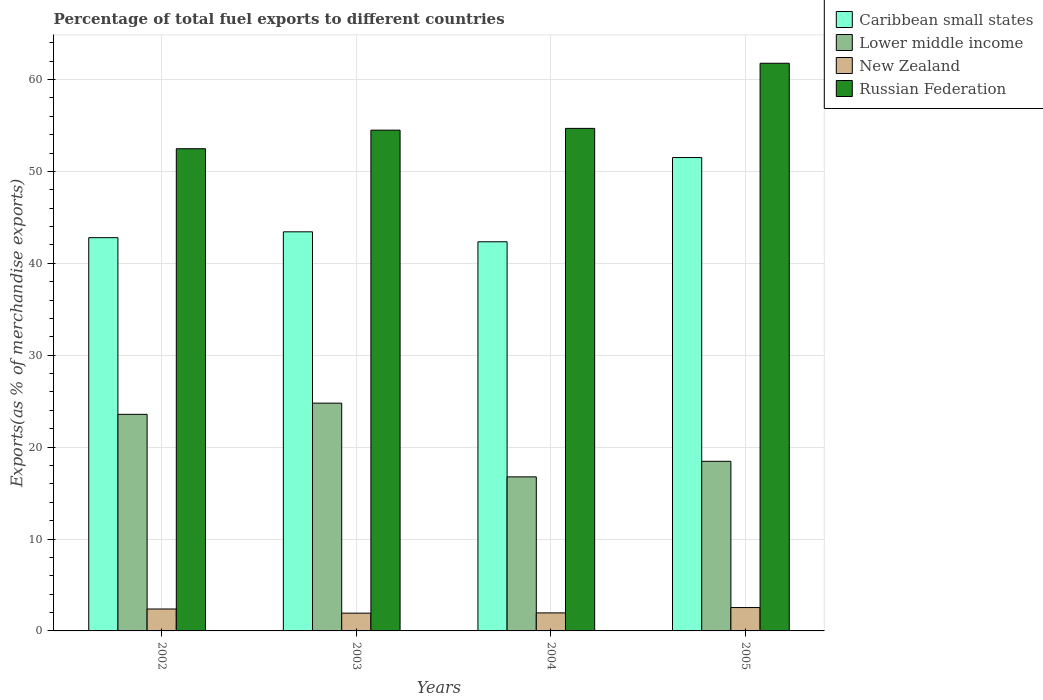Are the number of bars on each tick of the X-axis equal?
Make the answer very short. Yes. What is the percentage of exports to different countries in Russian Federation in 2003?
Provide a short and direct response. 54.49. Across all years, what is the maximum percentage of exports to different countries in New Zealand?
Provide a short and direct response. 2.54. Across all years, what is the minimum percentage of exports to different countries in Lower middle income?
Offer a terse response. 16.76. What is the total percentage of exports to different countries in Russian Federation in the graph?
Offer a terse response. 223.43. What is the difference between the percentage of exports to different countries in Lower middle income in 2004 and that in 2005?
Your response must be concise. -1.69. What is the difference between the percentage of exports to different countries in New Zealand in 2003 and the percentage of exports to different countries in Caribbean small states in 2004?
Give a very brief answer. -40.41. What is the average percentage of exports to different countries in Russian Federation per year?
Provide a succinct answer. 55.86. In the year 2005, what is the difference between the percentage of exports to different countries in Caribbean small states and percentage of exports to different countries in Lower middle income?
Keep it short and to the point. 33.05. What is the ratio of the percentage of exports to different countries in Lower middle income in 2003 to that in 2004?
Ensure brevity in your answer.  1.48. Is the percentage of exports to different countries in Russian Federation in 2002 less than that in 2004?
Offer a terse response. Yes. Is the difference between the percentage of exports to different countries in Caribbean small states in 2002 and 2005 greater than the difference between the percentage of exports to different countries in Lower middle income in 2002 and 2005?
Give a very brief answer. No. What is the difference between the highest and the second highest percentage of exports to different countries in Caribbean small states?
Give a very brief answer. 8.08. What is the difference between the highest and the lowest percentage of exports to different countries in Russian Federation?
Offer a terse response. 9.3. In how many years, is the percentage of exports to different countries in Lower middle income greater than the average percentage of exports to different countries in Lower middle income taken over all years?
Make the answer very short. 2. Is it the case that in every year, the sum of the percentage of exports to different countries in Russian Federation and percentage of exports to different countries in Lower middle income is greater than the sum of percentage of exports to different countries in Caribbean small states and percentage of exports to different countries in New Zealand?
Your answer should be compact. Yes. What does the 1st bar from the left in 2002 represents?
Offer a very short reply. Caribbean small states. What does the 2nd bar from the right in 2005 represents?
Provide a short and direct response. New Zealand. How many bars are there?
Provide a short and direct response. 16. Are all the bars in the graph horizontal?
Provide a short and direct response. No. What is the difference between two consecutive major ticks on the Y-axis?
Offer a very short reply. 10. How are the legend labels stacked?
Ensure brevity in your answer.  Vertical. What is the title of the graph?
Your response must be concise. Percentage of total fuel exports to different countries. Does "Angola" appear as one of the legend labels in the graph?
Ensure brevity in your answer.  No. What is the label or title of the Y-axis?
Provide a short and direct response. Exports(as % of merchandise exports). What is the Exports(as % of merchandise exports) in Caribbean small states in 2002?
Your answer should be very brief. 42.8. What is the Exports(as % of merchandise exports) in Lower middle income in 2002?
Make the answer very short. 23.57. What is the Exports(as % of merchandise exports) of New Zealand in 2002?
Provide a short and direct response. 2.39. What is the Exports(as % of merchandise exports) of Russian Federation in 2002?
Ensure brevity in your answer.  52.47. What is the Exports(as % of merchandise exports) in Caribbean small states in 2003?
Offer a very short reply. 43.43. What is the Exports(as % of merchandise exports) in Lower middle income in 2003?
Your answer should be very brief. 24.79. What is the Exports(as % of merchandise exports) in New Zealand in 2003?
Make the answer very short. 1.93. What is the Exports(as % of merchandise exports) in Russian Federation in 2003?
Your answer should be very brief. 54.49. What is the Exports(as % of merchandise exports) of Caribbean small states in 2004?
Offer a terse response. 42.35. What is the Exports(as % of merchandise exports) in Lower middle income in 2004?
Provide a short and direct response. 16.76. What is the Exports(as % of merchandise exports) in New Zealand in 2004?
Your answer should be compact. 1.96. What is the Exports(as % of merchandise exports) of Russian Federation in 2004?
Keep it short and to the point. 54.69. What is the Exports(as % of merchandise exports) in Caribbean small states in 2005?
Your answer should be very brief. 51.51. What is the Exports(as % of merchandise exports) of Lower middle income in 2005?
Offer a terse response. 18.46. What is the Exports(as % of merchandise exports) in New Zealand in 2005?
Offer a terse response. 2.54. What is the Exports(as % of merchandise exports) of Russian Federation in 2005?
Offer a terse response. 61.77. Across all years, what is the maximum Exports(as % of merchandise exports) of Caribbean small states?
Offer a very short reply. 51.51. Across all years, what is the maximum Exports(as % of merchandise exports) of Lower middle income?
Keep it short and to the point. 24.79. Across all years, what is the maximum Exports(as % of merchandise exports) of New Zealand?
Provide a succinct answer. 2.54. Across all years, what is the maximum Exports(as % of merchandise exports) in Russian Federation?
Your answer should be compact. 61.77. Across all years, what is the minimum Exports(as % of merchandise exports) in Caribbean small states?
Make the answer very short. 42.35. Across all years, what is the minimum Exports(as % of merchandise exports) in Lower middle income?
Provide a succinct answer. 16.76. Across all years, what is the minimum Exports(as % of merchandise exports) in New Zealand?
Offer a terse response. 1.93. Across all years, what is the minimum Exports(as % of merchandise exports) of Russian Federation?
Make the answer very short. 52.47. What is the total Exports(as % of merchandise exports) in Caribbean small states in the graph?
Your response must be concise. 180.09. What is the total Exports(as % of merchandise exports) in Lower middle income in the graph?
Give a very brief answer. 83.58. What is the total Exports(as % of merchandise exports) of New Zealand in the graph?
Your response must be concise. 8.82. What is the total Exports(as % of merchandise exports) in Russian Federation in the graph?
Give a very brief answer. 223.43. What is the difference between the Exports(as % of merchandise exports) of Caribbean small states in 2002 and that in 2003?
Provide a short and direct response. -0.64. What is the difference between the Exports(as % of merchandise exports) of Lower middle income in 2002 and that in 2003?
Provide a short and direct response. -1.22. What is the difference between the Exports(as % of merchandise exports) of New Zealand in 2002 and that in 2003?
Offer a terse response. 0.45. What is the difference between the Exports(as % of merchandise exports) of Russian Federation in 2002 and that in 2003?
Offer a terse response. -2.02. What is the difference between the Exports(as % of merchandise exports) in Caribbean small states in 2002 and that in 2004?
Your answer should be compact. 0.45. What is the difference between the Exports(as % of merchandise exports) in Lower middle income in 2002 and that in 2004?
Your answer should be very brief. 6.8. What is the difference between the Exports(as % of merchandise exports) in New Zealand in 2002 and that in 2004?
Your answer should be compact. 0.42. What is the difference between the Exports(as % of merchandise exports) of Russian Federation in 2002 and that in 2004?
Provide a succinct answer. -2.21. What is the difference between the Exports(as % of merchandise exports) of Caribbean small states in 2002 and that in 2005?
Ensure brevity in your answer.  -8.72. What is the difference between the Exports(as % of merchandise exports) in Lower middle income in 2002 and that in 2005?
Provide a short and direct response. 5.11. What is the difference between the Exports(as % of merchandise exports) of New Zealand in 2002 and that in 2005?
Ensure brevity in your answer.  -0.16. What is the difference between the Exports(as % of merchandise exports) in Russian Federation in 2002 and that in 2005?
Keep it short and to the point. -9.3. What is the difference between the Exports(as % of merchandise exports) of Caribbean small states in 2003 and that in 2004?
Provide a succinct answer. 1.08. What is the difference between the Exports(as % of merchandise exports) in Lower middle income in 2003 and that in 2004?
Your answer should be very brief. 8.02. What is the difference between the Exports(as % of merchandise exports) of New Zealand in 2003 and that in 2004?
Provide a short and direct response. -0.03. What is the difference between the Exports(as % of merchandise exports) in Russian Federation in 2003 and that in 2004?
Keep it short and to the point. -0.19. What is the difference between the Exports(as % of merchandise exports) in Caribbean small states in 2003 and that in 2005?
Ensure brevity in your answer.  -8.08. What is the difference between the Exports(as % of merchandise exports) of Lower middle income in 2003 and that in 2005?
Offer a terse response. 6.33. What is the difference between the Exports(as % of merchandise exports) in New Zealand in 2003 and that in 2005?
Keep it short and to the point. -0.61. What is the difference between the Exports(as % of merchandise exports) of Russian Federation in 2003 and that in 2005?
Keep it short and to the point. -7.28. What is the difference between the Exports(as % of merchandise exports) of Caribbean small states in 2004 and that in 2005?
Offer a terse response. -9.16. What is the difference between the Exports(as % of merchandise exports) of Lower middle income in 2004 and that in 2005?
Offer a very short reply. -1.69. What is the difference between the Exports(as % of merchandise exports) in New Zealand in 2004 and that in 2005?
Make the answer very short. -0.58. What is the difference between the Exports(as % of merchandise exports) of Russian Federation in 2004 and that in 2005?
Provide a short and direct response. -7.09. What is the difference between the Exports(as % of merchandise exports) of Caribbean small states in 2002 and the Exports(as % of merchandise exports) of Lower middle income in 2003?
Provide a short and direct response. 18.01. What is the difference between the Exports(as % of merchandise exports) of Caribbean small states in 2002 and the Exports(as % of merchandise exports) of New Zealand in 2003?
Your answer should be very brief. 40.86. What is the difference between the Exports(as % of merchandise exports) in Caribbean small states in 2002 and the Exports(as % of merchandise exports) in Russian Federation in 2003?
Offer a terse response. -11.7. What is the difference between the Exports(as % of merchandise exports) in Lower middle income in 2002 and the Exports(as % of merchandise exports) in New Zealand in 2003?
Give a very brief answer. 21.64. What is the difference between the Exports(as % of merchandise exports) in Lower middle income in 2002 and the Exports(as % of merchandise exports) in Russian Federation in 2003?
Provide a succinct answer. -30.93. What is the difference between the Exports(as % of merchandise exports) in New Zealand in 2002 and the Exports(as % of merchandise exports) in Russian Federation in 2003?
Your response must be concise. -52.11. What is the difference between the Exports(as % of merchandise exports) in Caribbean small states in 2002 and the Exports(as % of merchandise exports) in Lower middle income in 2004?
Offer a terse response. 26.03. What is the difference between the Exports(as % of merchandise exports) in Caribbean small states in 2002 and the Exports(as % of merchandise exports) in New Zealand in 2004?
Give a very brief answer. 40.83. What is the difference between the Exports(as % of merchandise exports) of Caribbean small states in 2002 and the Exports(as % of merchandise exports) of Russian Federation in 2004?
Provide a short and direct response. -11.89. What is the difference between the Exports(as % of merchandise exports) of Lower middle income in 2002 and the Exports(as % of merchandise exports) of New Zealand in 2004?
Keep it short and to the point. 21.61. What is the difference between the Exports(as % of merchandise exports) in Lower middle income in 2002 and the Exports(as % of merchandise exports) in Russian Federation in 2004?
Keep it short and to the point. -31.12. What is the difference between the Exports(as % of merchandise exports) in New Zealand in 2002 and the Exports(as % of merchandise exports) in Russian Federation in 2004?
Offer a very short reply. -52.3. What is the difference between the Exports(as % of merchandise exports) in Caribbean small states in 2002 and the Exports(as % of merchandise exports) in Lower middle income in 2005?
Keep it short and to the point. 24.34. What is the difference between the Exports(as % of merchandise exports) in Caribbean small states in 2002 and the Exports(as % of merchandise exports) in New Zealand in 2005?
Give a very brief answer. 40.25. What is the difference between the Exports(as % of merchandise exports) of Caribbean small states in 2002 and the Exports(as % of merchandise exports) of Russian Federation in 2005?
Provide a short and direct response. -18.98. What is the difference between the Exports(as % of merchandise exports) of Lower middle income in 2002 and the Exports(as % of merchandise exports) of New Zealand in 2005?
Make the answer very short. 21.03. What is the difference between the Exports(as % of merchandise exports) of Lower middle income in 2002 and the Exports(as % of merchandise exports) of Russian Federation in 2005?
Your answer should be very brief. -38.21. What is the difference between the Exports(as % of merchandise exports) of New Zealand in 2002 and the Exports(as % of merchandise exports) of Russian Federation in 2005?
Give a very brief answer. -59.39. What is the difference between the Exports(as % of merchandise exports) of Caribbean small states in 2003 and the Exports(as % of merchandise exports) of Lower middle income in 2004?
Offer a terse response. 26.67. What is the difference between the Exports(as % of merchandise exports) of Caribbean small states in 2003 and the Exports(as % of merchandise exports) of New Zealand in 2004?
Offer a terse response. 41.47. What is the difference between the Exports(as % of merchandise exports) of Caribbean small states in 2003 and the Exports(as % of merchandise exports) of Russian Federation in 2004?
Provide a short and direct response. -11.26. What is the difference between the Exports(as % of merchandise exports) in Lower middle income in 2003 and the Exports(as % of merchandise exports) in New Zealand in 2004?
Provide a succinct answer. 22.83. What is the difference between the Exports(as % of merchandise exports) in Lower middle income in 2003 and the Exports(as % of merchandise exports) in Russian Federation in 2004?
Offer a terse response. -29.9. What is the difference between the Exports(as % of merchandise exports) in New Zealand in 2003 and the Exports(as % of merchandise exports) in Russian Federation in 2004?
Your answer should be compact. -52.75. What is the difference between the Exports(as % of merchandise exports) in Caribbean small states in 2003 and the Exports(as % of merchandise exports) in Lower middle income in 2005?
Ensure brevity in your answer.  24.97. What is the difference between the Exports(as % of merchandise exports) of Caribbean small states in 2003 and the Exports(as % of merchandise exports) of New Zealand in 2005?
Provide a succinct answer. 40.89. What is the difference between the Exports(as % of merchandise exports) of Caribbean small states in 2003 and the Exports(as % of merchandise exports) of Russian Federation in 2005?
Ensure brevity in your answer.  -18.34. What is the difference between the Exports(as % of merchandise exports) of Lower middle income in 2003 and the Exports(as % of merchandise exports) of New Zealand in 2005?
Keep it short and to the point. 22.24. What is the difference between the Exports(as % of merchandise exports) of Lower middle income in 2003 and the Exports(as % of merchandise exports) of Russian Federation in 2005?
Offer a terse response. -36.99. What is the difference between the Exports(as % of merchandise exports) in New Zealand in 2003 and the Exports(as % of merchandise exports) in Russian Federation in 2005?
Your answer should be very brief. -59.84. What is the difference between the Exports(as % of merchandise exports) in Caribbean small states in 2004 and the Exports(as % of merchandise exports) in Lower middle income in 2005?
Your answer should be very brief. 23.89. What is the difference between the Exports(as % of merchandise exports) of Caribbean small states in 2004 and the Exports(as % of merchandise exports) of New Zealand in 2005?
Keep it short and to the point. 39.81. What is the difference between the Exports(as % of merchandise exports) in Caribbean small states in 2004 and the Exports(as % of merchandise exports) in Russian Federation in 2005?
Provide a short and direct response. -19.43. What is the difference between the Exports(as % of merchandise exports) in Lower middle income in 2004 and the Exports(as % of merchandise exports) in New Zealand in 2005?
Make the answer very short. 14.22. What is the difference between the Exports(as % of merchandise exports) of Lower middle income in 2004 and the Exports(as % of merchandise exports) of Russian Federation in 2005?
Offer a very short reply. -45.01. What is the difference between the Exports(as % of merchandise exports) in New Zealand in 2004 and the Exports(as % of merchandise exports) in Russian Federation in 2005?
Keep it short and to the point. -59.81. What is the average Exports(as % of merchandise exports) in Caribbean small states per year?
Make the answer very short. 45.02. What is the average Exports(as % of merchandise exports) in Lower middle income per year?
Give a very brief answer. 20.89. What is the average Exports(as % of merchandise exports) in New Zealand per year?
Make the answer very short. 2.21. What is the average Exports(as % of merchandise exports) of Russian Federation per year?
Make the answer very short. 55.86. In the year 2002, what is the difference between the Exports(as % of merchandise exports) of Caribbean small states and Exports(as % of merchandise exports) of Lower middle income?
Keep it short and to the point. 19.23. In the year 2002, what is the difference between the Exports(as % of merchandise exports) in Caribbean small states and Exports(as % of merchandise exports) in New Zealand?
Offer a terse response. 40.41. In the year 2002, what is the difference between the Exports(as % of merchandise exports) of Caribbean small states and Exports(as % of merchandise exports) of Russian Federation?
Ensure brevity in your answer.  -9.68. In the year 2002, what is the difference between the Exports(as % of merchandise exports) in Lower middle income and Exports(as % of merchandise exports) in New Zealand?
Keep it short and to the point. 21.18. In the year 2002, what is the difference between the Exports(as % of merchandise exports) of Lower middle income and Exports(as % of merchandise exports) of Russian Federation?
Ensure brevity in your answer.  -28.9. In the year 2002, what is the difference between the Exports(as % of merchandise exports) in New Zealand and Exports(as % of merchandise exports) in Russian Federation?
Provide a short and direct response. -50.09. In the year 2003, what is the difference between the Exports(as % of merchandise exports) in Caribbean small states and Exports(as % of merchandise exports) in Lower middle income?
Give a very brief answer. 18.64. In the year 2003, what is the difference between the Exports(as % of merchandise exports) in Caribbean small states and Exports(as % of merchandise exports) in New Zealand?
Make the answer very short. 41.5. In the year 2003, what is the difference between the Exports(as % of merchandise exports) in Caribbean small states and Exports(as % of merchandise exports) in Russian Federation?
Give a very brief answer. -11.06. In the year 2003, what is the difference between the Exports(as % of merchandise exports) in Lower middle income and Exports(as % of merchandise exports) in New Zealand?
Keep it short and to the point. 22.85. In the year 2003, what is the difference between the Exports(as % of merchandise exports) of Lower middle income and Exports(as % of merchandise exports) of Russian Federation?
Your answer should be compact. -29.71. In the year 2003, what is the difference between the Exports(as % of merchandise exports) of New Zealand and Exports(as % of merchandise exports) of Russian Federation?
Provide a short and direct response. -52.56. In the year 2004, what is the difference between the Exports(as % of merchandise exports) of Caribbean small states and Exports(as % of merchandise exports) of Lower middle income?
Give a very brief answer. 25.58. In the year 2004, what is the difference between the Exports(as % of merchandise exports) of Caribbean small states and Exports(as % of merchandise exports) of New Zealand?
Ensure brevity in your answer.  40.39. In the year 2004, what is the difference between the Exports(as % of merchandise exports) in Caribbean small states and Exports(as % of merchandise exports) in Russian Federation?
Ensure brevity in your answer.  -12.34. In the year 2004, what is the difference between the Exports(as % of merchandise exports) of Lower middle income and Exports(as % of merchandise exports) of New Zealand?
Give a very brief answer. 14.8. In the year 2004, what is the difference between the Exports(as % of merchandise exports) in Lower middle income and Exports(as % of merchandise exports) in Russian Federation?
Your answer should be very brief. -37.92. In the year 2004, what is the difference between the Exports(as % of merchandise exports) in New Zealand and Exports(as % of merchandise exports) in Russian Federation?
Give a very brief answer. -52.73. In the year 2005, what is the difference between the Exports(as % of merchandise exports) in Caribbean small states and Exports(as % of merchandise exports) in Lower middle income?
Keep it short and to the point. 33.05. In the year 2005, what is the difference between the Exports(as % of merchandise exports) in Caribbean small states and Exports(as % of merchandise exports) in New Zealand?
Make the answer very short. 48.97. In the year 2005, what is the difference between the Exports(as % of merchandise exports) of Caribbean small states and Exports(as % of merchandise exports) of Russian Federation?
Your answer should be very brief. -10.26. In the year 2005, what is the difference between the Exports(as % of merchandise exports) in Lower middle income and Exports(as % of merchandise exports) in New Zealand?
Make the answer very short. 15.92. In the year 2005, what is the difference between the Exports(as % of merchandise exports) of Lower middle income and Exports(as % of merchandise exports) of Russian Federation?
Your answer should be compact. -43.32. In the year 2005, what is the difference between the Exports(as % of merchandise exports) in New Zealand and Exports(as % of merchandise exports) in Russian Federation?
Your answer should be very brief. -59.23. What is the ratio of the Exports(as % of merchandise exports) in Caribbean small states in 2002 to that in 2003?
Offer a terse response. 0.99. What is the ratio of the Exports(as % of merchandise exports) in Lower middle income in 2002 to that in 2003?
Provide a succinct answer. 0.95. What is the ratio of the Exports(as % of merchandise exports) in New Zealand in 2002 to that in 2003?
Your response must be concise. 1.23. What is the ratio of the Exports(as % of merchandise exports) in Russian Federation in 2002 to that in 2003?
Your answer should be compact. 0.96. What is the ratio of the Exports(as % of merchandise exports) of Caribbean small states in 2002 to that in 2004?
Provide a succinct answer. 1.01. What is the ratio of the Exports(as % of merchandise exports) of Lower middle income in 2002 to that in 2004?
Offer a very short reply. 1.41. What is the ratio of the Exports(as % of merchandise exports) of New Zealand in 2002 to that in 2004?
Provide a short and direct response. 1.22. What is the ratio of the Exports(as % of merchandise exports) of Russian Federation in 2002 to that in 2004?
Make the answer very short. 0.96. What is the ratio of the Exports(as % of merchandise exports) in Caribbean small states in 2002 to that in 2005?
Give a very brief answer. 0.83. What is the ratio of the Exports(as % of merchandise exports) in Lower middle income in 2002 to that in 2005?
Give a very brief answer. 1.28. What is the ratio of the Exports(as % of merchandise exports) of New Zealand in 2002 to that in 2005?
Keep it short and to the point. 0.94. What is the ratio of the Exports(as % of merchandise exports) in Russian Federation in 2002 to that in 2005?
Provide a succinct answer. 0.85. What is the ratio of the Exports(as % of merchandise exports) in Caribbean small states in 2003 to that in 2004?
Ensure brevity in your answer.  1.03. What is the ratio of the Exports(as % of merchandise exports) in Lower middle income in 2003 to that in 2004?
Keep it short and to the point. 1.48. What is the ratio of the Exports(as % of merchandise exports) in New Zealand in 2003 to that in 2004?
Make the answer very short. 0.99. What is the ratio of the Exports(as % of merchandise exports) in Caribbean small states in 2003 to that in 2005?
Your answer should be very brief. 0.84. What is the ratio of the Exports(as % of merchandise exports) in Lower middle income in 2003 to that in 2005?
Offer a terse response. 1.34. What is the ratio of the Exports(as % of merchandise exports) in New Zealand in 2003 to that in 2005?
Make the answer very short. 0.76. What is the ratio of the Exports(as % of merchandise exports) in Russian Federation in 2003 to that in 2005?
Offer a very short reply. 0.88. What is the ratio of the Exports(as % of merchandise exports) in Caribbean small states in 2004 to that in 2005?
Offer a very short reply. 0.82. What is the ratio of the Exports(as % of merchandise exports) of Lower middle income in 2004 to that in 2005?
Your answer should be very brief. 0.91. What is the ratio of the Exports(as % of merchandise exports) of New Zealand in 2004 to that in 2005?
Provide a succinct answer. 0.77. What is the ratio of the Exports(as % of merchandise exports) of Russian Federation in 2004 to that in 2005?
Your answer should be compact. 0.89. What is the difference between the highest and the second highest Exports(as % of merchandise exports) of Caribbean small states?
Your answer should be very brief. 8.08. What is the difference between the highest and the second highest Exports(as % of merchandise exports) in Lower middle income?
Your response must be concise. 1.22. What is the difference between the highest and the second highest Exports(as % of merchandise exports) of New Zealand?
Give a very brief answer. 0.16. What is the difference between the highest and the second highest Exports(as % of merchandise exports) of Russian Federation?
Give a very brief answer. 7.09. What is the difference between the highest and the lowest Exports(as % of merchandise exports) in Caribbean small states?
Keep it short and to the point. 9.16. What is the difference between the highest and the lowest Exports(as % of merchandise exports) of Lower middle income?
Ensure brevity in your answer.  8.02. What is the difference between the highest and the lowest Exports(as % of merchandise exports) of New Zealand?
Make the answer very short. 0.61. What is the difference between the highest and the lowest Exports(as % of merchandise exports) of Russian Federation?
Your response must be concise. 9.3. 